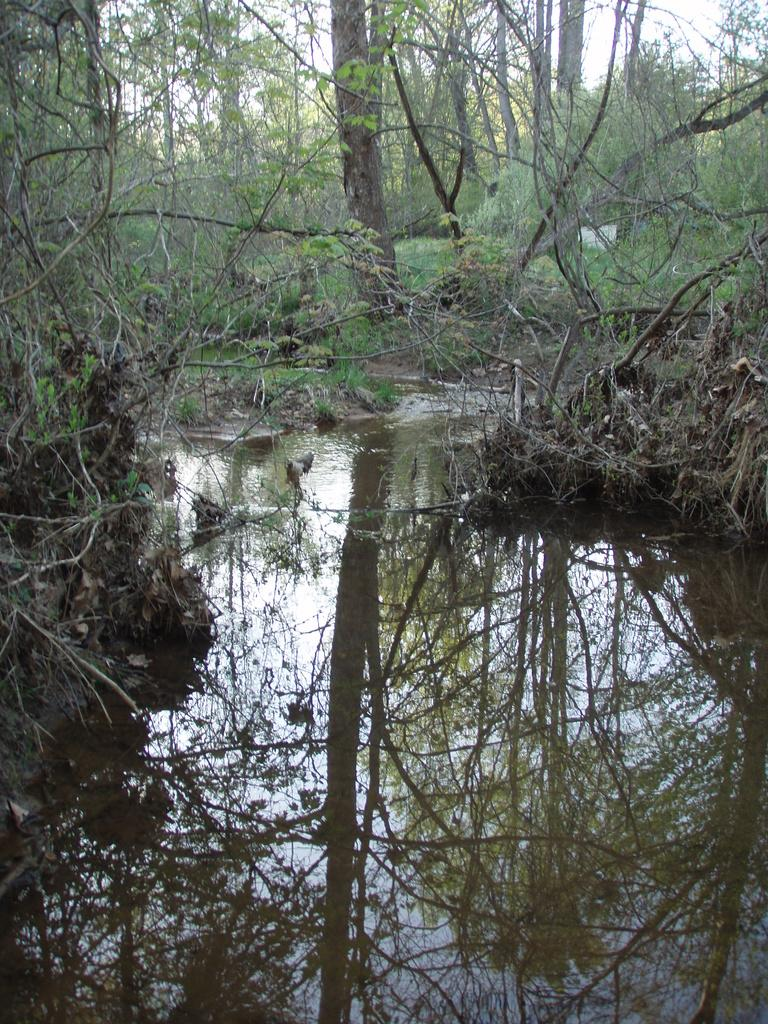What is the main feature in the foreground of the picture? There is a water body in the foreground of the picture. What can be seen in the middle of the picture? There are trees and land in the center of the picture. What is visible in the background of the picture? There are trees in the background of the picture. What type of alarm can be heard going off in the background of the picture? There is no alarm present in the image, as it is a picture of a natural landscape. 